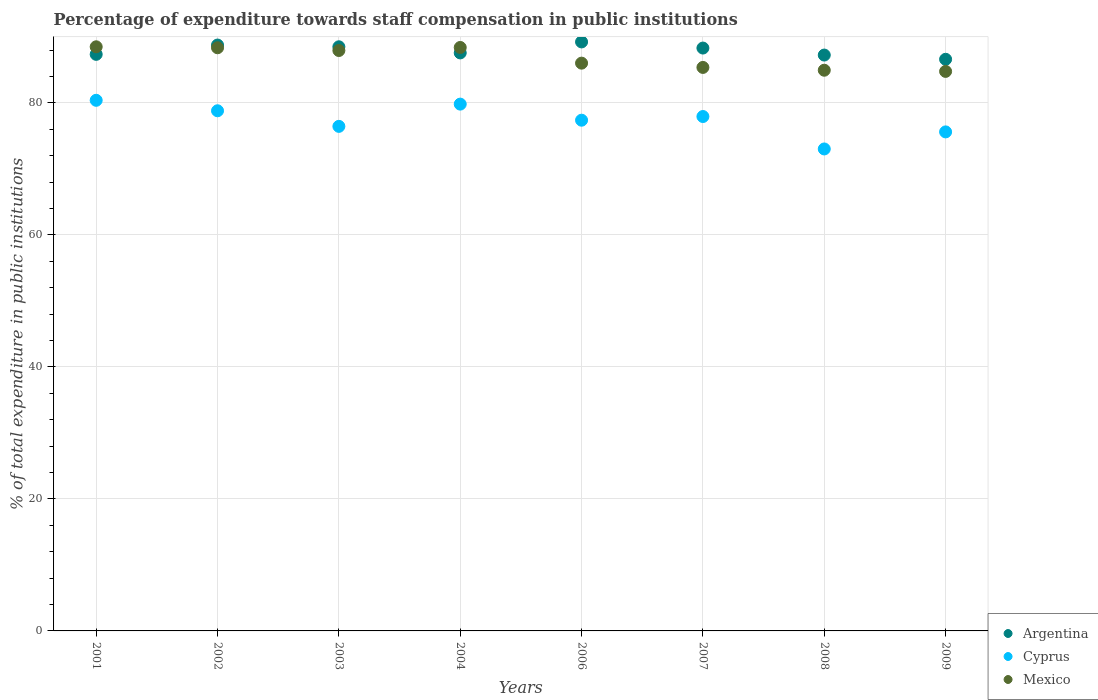Is the number of dotlines equal to the number of legend labels?
Make the answer very short. Yes. What is the percentage of expenditure towards staff compensation in Mexico in 2004?
Provide a short and direct response. 88.4. Across all years, what is the maximum percentage of expenditure towards staff compensation in Mexico?
Your response must be concise. 88.5. Across all years, what is the minimum percentage of expenditure towards staff compensation in Mexico?
Provide a short and direct response. 84.78. In which year was the percentage of expenditure towards staff compensation in Cyprus maximum?
Ensure brevity in your answer.  2001. In which year was the percentage of expenditure towards staff compensation in Argentina minimum?
Give a very brief answer. 2009. What is the total percentage of expenditure towards staff compensation in Mexico in the graph?
Your answer should be compact. 694.34. What is the difference between the percentage of expenditure towards staff compensation in Mexico in 2001 and that in 2009?
Provide a short and direct response. 3.73. What is the difference between the percentage of expenditure towards staff compensation in Mexico in 2002 and the percentage of expenditure towards staff compensation in Cyprus in 2009?
Offer a terse response. 12.75. What is the average percentage of expenditure towards staff compensation in Argentina per year?
Provide a succinct answer. 87.95. In the year 2007, what is the difference between the percentage of expenditure towards staff compensation in Cyprus and percentage of expenditure towards staff compensation in Mexico?
Ensure brevity in your answer.  -7.44. What is the ratio of the percentage of expenditure towards staff compensation in Mexico in 2008 to that in 2009?
Your answer should be very brief. 1. What is the difference between the highest and the second highest percentage of expenditure towards staff compensation in Mexico?
Provide a short and direct response. 0.1. What is the difference between the highest and the lowest percentage of expenditure towards staff compensation in Argentina?
Offer a terse response. 2.63. Is the sum of the percentage of expenditure towards staff compensation in Mexico in 2001 and 2006 greater than the maximum percentage of expenditure towards staff compensation in Cyprus across all years?
Provide a succinct answer. Yes. Does the graph contain grids?
Give a very brief answer. Yes. Where does the legend appear in the graph?
Give a very brief answer. Bottom right. What is the title of the graph?
Make the answer very short. Percentage of expenditure towards staff compensation in public institutions. Does "Upper middle income" appear as one of the legend labels in the graph?
Make the answer very short. No. What is the label or title of the Y-axis?
Offer a terse response. % of total expenditure in public institutions. What is the % of total expenditure in public institutions in Argentina in 2001?
Offer a terse response. 87.36. What is the % of total expenditure in public institutions in Cyprus in 2001?
Keep it short and to the point. 80.4. What is the % of total expenditure in public institutions of Mexico in 2001?
Your answer should be very brief. 88.5. What is the % of total expenditure in public institutions of Argentina in 2002?
Your answer should be very brief. 88.77. What is the % of total expenditure in public institutions in Cyprus in 2002?
Keep it short and to the point. 78.81. What is the % of total expenditure in public institutions in Mexico in 2002?
Make the answer very short. 88.36. What is the % of total expenditure in public institutions of Argentina in 2003?
Keep it short and to the point. 88.51. What is the % of total expenditure in public institutions of Cyprus in 2003?
Offer a terse response. 76.45. What is the % of total expenditure in public institutions of Mexico in 2003?
Make the answer very short. 87.94. What is the % of total expenditure in public institutions of Argentina in 2004?
Make the answer very short. 87.58. What is the % of total expenditure in public institutions of Cyprus in 2004?
Offer a very short reply. 79.82. What is the % of total expenditure in public institutions in Mexico in 2004?
Your response must be concise. 88.4. What is the % of total expenditure in public institutions in Argentina in 2006?
Offer a terse response. 89.24. What is the % of total expenditure in public institutions of Cyprus in 2006?
Give a very brief answer. 77.38. What is the % of total expenditure in public institutions of Mexico in 2006?
Provide a short and direct response. 86.03. What is the % of total expenditure in public institutions in Argentina in 2007?
Provide a short and direct response. 88.31. What is the % of total expenditure in public institutions of Cyprus in 2007?
Provide a short and direct response. 77.94. What is the % of total expenditure in public institutions in Mexico in 2007?
Offer a very short reply. 85.38. What is the % of total expenditure in public institutions in Argentina in 2008?
Make the answer very short. 87.25. What is the % of total expenditure in public institutions of Cyprus in 2008?
Your response must be concise. 73.03. What is the % of total expenditure in public institutions in Mexico in 2008?
Offer a terse response. 84.95. What is the % of total expenditure in public institutions of Argentina in 2009?
Offer a very short reply. 86.61. What is the % of total expenditure in public institutions in Cyprus in 2009?
Ensure brevity in your answer.  75.61. What is the % of total expenditure in public institutions of Mexico in 2009?
Your answer should be very brief. 84.78. Across all years, what is the maximum % of total expenditure in public institutions in Argentina?
Give a very brief answer. 89.24. Across all years, what is the maximum % of total expenditure in public institutions of Cyprus?
Offer a very short reply. 80.4. Across all years, what is the maximum % of total expenditure in public institutions in Mexico?
Your answer should be compact. 88.5. Across all years, what is the minimum % of total expenditure in public institutions of Argentina?
Offer a very short reply. 86.61. Across all years, what is the minimum % of total expenditure in public institutions in Cyprus?
Provide a short and direct response. 73.03. Across all years, what is the minimum % of total expenditure in public institutions of Mexico?
Give a very brief answer. 84.78. What is the total % of total expenditure in public institutions in Argentina in the graph?
Ensure brevity in your answer.  703.63. What is the total % of total expenditure in public institutions in Cyprus in the graph?
Provide a short and direct response. 619.43. What is the total % of total expenditure in public institutions of Mexico in the graph?
Make the answer very short. 694.34. What is the difference between the % of total expenditure in public institutions of Argentina in 2001 and that in 2002?
Ensure brevity in your answer.  -1.41. What is the difference between the % of total expenditure in public institutions in Cyprus in 2001 and that in 2002?
Provide a short and direct response. 1.59. What is the difference between the % of total expenditure in public institutions of Mexico in 2001 and that in 2002?
Provide a short and direct response. 0.15. What is the difference between the % of total expenditure in public institutions of Argentina in 2001 and that in 2003?
Ensure brevity in your answer.  -1.15. What is the difference between the % of total expenditure in public institutions of Cyprus in 2001 and that in 2003?
Provide a succinct answer. 3.95. What is the difference between the % of total expenditure in public institutions of Mexico in 2001 and that in 2003?
Provide a succinct answer. 0.56. What is the difference between the % of total expenditure in public institutions in Argentina in 2001 and that in 2004?
Offer a very short reply. -0.22. What is the difference between the % of total expenditure in public institutions of Cyprus in 2001 and that in 2004?
Provide a short and direct response. 0.58. What is the difference between the % of total expenditure in public institutions of Mexico in 2001 and that in 2004?
Offer a very short reply. 0.1. What is the difference between the % of total expenditure in public institutions in Argentina in 2001 and that in 2006?
Your response must be concise. -1.88. What is the difference between the % of total expenditure in public institutions in Cyprus in 2001 and that in 2006?
Make the answer very short. 3.01. What is the difference between the % of total expenditure in public institutions of Mexico in 2001 and that in 2006?
Make the answer very short. 2.48. What is the difference between the % of total expenditure in public institutions of Argentina in 2001 and that in 2007?
Make the answer very short. -0.95. What is the difference between the % of total expenditure in public institutions of Cyprus in 2001 and that in 2007?
Make the answer very short. 2.46. What is the difference between the % of total expenditure in public institutions of Mexico in 2001 and that in 2007?
Your answer should be compact. 3.13. What is the difference between the % of total expenditure in public institutions of Argentina in 2001 and that in 2008?
Ensure brevity in your answer.  0.1. What is the difference between the % of total expenditure in public institutions in Cyprus in 2001 and that in 2008?
Offer a very short reply. 7.37. What is the difference between the % of total expenditure in public institutions of Mexico in 2001 and that in 2008?
Your answer should be very brief. 3.55. What is the difference between the % of total expenditure in public institutions in Argentina in 2001 and that in 2009?
Ensure brevity in your answer.  0.75. What is the difference between the % of total expenditure in public institutions of Cyprus in 2001 and that in 2009?
Keep it short and to the point. 4.79. What is the difference between the % of total expenditure in public institutions in Mexico in 2001 and that in 2009?
Provide a short and direct response. 3.73. What is the difference between the % of total expenditure in public institutions in Argentina in 2002 and that in 2003?
Give a very brief answer. 0.26. What is the difference between the % of total expenditure in public institutions in Cyprus in 2002 and that in 2003?
Your response must be concise. 2.36. What is the difference between the % of total expenditure in public institutions of Mexico in 2002 and that in 2003?
Provide a succinct answer. 0.41. What is the difference between the % of total expenditure in public institutions in Argentina in 2002 and that in 2004?
Make the answer very short. 1.19. What is the difference between the % of total expenditure in public institutions of Cyprus in 2002 and that in 2004?
Your answer should be very brief. -1.01. What is the difference between the % of total expenditure in public institutions of Mexico in 2002 and that in 2004?
Keep it short and to the point. -0.05. What is the difference between the % of total expenditure in public institutions in Argentina in 2002 and that in 2006?
Provide a short and direct response. -0.47. What is the difference between the % of total expenditure in public institutions in Cyprus in 2002 and that in 2006?
Provide a short and direct response. 1.43. What is the difference between the % of total expenditure in public institutions of Mexico in 2002 and that in 2006?
Offer a terse response. 2.33. What is the difference between the % of total expenditure in public institutions in Argentina in 2002 and that in 2007?
Your response must be concise. 0.46. What is the difference between the % of total expenditure in public institutions in Cyprus in 2002 and that in 2007?
Keep it short and to the point. 0.87. What is the difference between the % of total expenditure in public institutions in Mexico in 2002 and that in 2007?
Provide a succinct answer. 2.98. What is the difference between the % of total expenditure in public institutions of Argentina in 2002 and that in 2008?
Ensure brevity in your answer.  1.52. What is the difference between the % of total expenditure in public institutions of Cyprus in 2002 and that in 2008?
Provide a short and direct response. 5.79. What is the difference between the % of total expenditure in public institutions of Mexico in 2002 and that in 2008?
Your answer should be very brief. 3.4. What is the difference between the % of total expenditure in public institutions of Argentina in 2002 and that in 2009?
Keep it short and to the point. 2.16. What is the difference between the % of total expenditure in public institutions in Cyprus in 2002 and that in 2009?
Ensure brevity in your answer.  3.2. What is the difference between the % of total expenditure in public institutions in Mexico in 2002 and that in 2009?
Provide a succinct answer. 3.58. What is the difference between the % of total expenditure in public institutions in Argentina in 2003 and that in 2004?
Offer a terse response. 0.93. What is the difference between the % of total expenditure in public institutions in Cyprus in 2003 and that in 2004?
Provide a short and direct response. -3.37. What is the difference between the % of total expenditure in public institutions of Mexico in 2003 and that in 2004?
Ensure brevity in your answer.  -0.46. What is the difference between the % of total expenditure in public institutions of Argentina in 2003 and that in 2006?
Your response must be concise. -0.74. What is the difference between the % of total expenditure in public institutions of Cyprus in 2003 and that in 2006?
Make the answer very short. -0.93. What is the difference between the % of total expenditure in public institutions in Mexico in 2003 and that in 2006?
Offer a terse response. 1.92. What is the difference between the % of total expenditure in public institutions in Argentina in 2003 and that in 2007?
Your answer should be very brief. 0.19. What is the difference between the % of total expenditure in public institutions of Cyprus in 2003 and that in 2007?
Your answer should be very brief. -1.49. What is the difference between the % of total expenditure in public institutions of Mexico in 2003 and that in 2007?
Ensure brevity in your answer.  2.56. What is the difference between the % of total expenditure in public institutions of Argentina in 2003 and that in 2008?
Ensure brevity in your answer.  1.25. What is the difference between the % of total expenditure in public institutions of Cyprus in 2003 and that in 2008?
Your answer should be compact. 3.42. What is the difference between the % of total expenditure in public institutions of Mexico in 2003 and that in 2008?
Your answer should be very brief. 2.99. What is the difference between the % of total expenditure in public institutions in Argentina in 2003 and that in 2009?
Your answer should be very brief. 1.89. What is the difference between the % of total expenditure in public institutions of Cyprus in 2003 and that in 2009?
Keep it short and to the point. 0.84. What is the difference between the % of total expenditure in public institutions in Mexico in 2003 and that in 2009?
Your answer should be very brief. 3.17. What is the difference between the % of total expenditure in public institutions of Argentina in 2004 and that in 2006?
Keep it short and to the point. -1.66. What is the difference between the % of total expenditure in public institutions in Cyprus in 2004 and that in 2006?
Provide a succinct answer. 2.44. What is the difference between the % of total expenditure in public institutions of Mexico in 2004 and that in 2006?
Provide a succinct answer. 2.38. What is the difference between the % of total expenditure in public institutions in Argentina in 2004 and that in 2007?
Keep it short and to the point. -0.74. What is the difference between the % of total expenditure in public institutions in Cyprus in 2004 and that in 2007?
Offer a very short reply. 1.88. What is the difference between the % of total expenditure in public institutions in Mexico in 2004 and that in 2007?
Your response must be concise. 3.02. What is the difference between the % of total expenditure in public institutions of Argentina in 2004 and that in 2008?
Ensure brevity in your answer.  0.32. What is the difference between the % of total expenditure in public institutions in Cyprus in 2004 and that in 2008?
Offer a very short reply. 6.79. What is the difference between the % of total expenditure in public institutions in Mexico in 2004 and that in 2008?
Give a very brief answer. 3.45. What is the difference between the % of total expenditure in public institutions of Argentina in 2004 and that in 2009?
Offer a very short reply. 0.97. What is the difference between the % of total expenditure in public institutions in Cyprus in 2004 and that in 2009?
Ensure brevity in your answer.  4.21. What is the difference between the % of total expenditure in public institutions in Mexico in 2004 and that in 2009?
Keep it short and to the point. 3.63. What is the difference between the % of total expenditure in public institutions in Argentina in 2006 and that in 2007?
Offer a terse response. 0.93. What is the difference between the % of total expenditure in public institutions of Cyprus in 2006 and that in 2007?
Offer a very short reply. -0.56. What is the difference between the % of total expenditure in public institutions in Mexico in 2006 and that in 2007?
Your answer should be very brief. 0.65. What is the difference between the % of total expenditure in public institutions of Argentina in 2006 and that in 2008?
Offer a terse response. 1.99. What is the difference between the % of total expenditure in public institutions of Cyprus in 2006 and that in 2008?
Your answer should be very brief. 4.36. What is the difference between the % of total expenditure in public institutions of Mexico in 2006 and that in 2008?
Provide a succinct answer. 1.07. What is the difference between the % of total expenditure in public institutions in Argentina in 2006 and that in 2009?
Make the answer very short. 2.63. What is the difference between the % of total expenditure in public institutions in Cyprus in 2006 and that in 2009?
Your response must be concise. 1.77. What is the difference between the % of total expenditure in public institutions in Mexico in 2006 and that in 2009?
Your answer should be very brief. 1.25. What is the difference between the % of total expenditure in public institutions of Argentina in 2007 and that in 2008?
Your answer should be compact. 1.06. What is the difference between the % of total expenditure in public institutions in Cyprus in 2007 and that in 2008?
Ensure brevity in your answer.  4.91. What is the difference between the % of total expenditure in public institutions of Mexico in 2007 and that in 2008?
Ensure brevity in your answer.  0.42. What is the difference between the % of total expenditure in public institutions in Argentina in 2007 and that in 2009?
Make the answer very short. 1.7. What is the difference between the % of total expenditure in public institutions of Cyprus in 2007 and that in 2009?
Offer a terse response. 2.33. What is the difference between the % of total expenditure in public institutions of Mexico in 2007 and that in 2009?
Keep it short and to the point. 0.6. What is the difference between the % of total expenditure in public institutions in Argentina in 2008 and that in 2009?
Keep it short and to the point. 0.64. What is the difference between the % of total expenditure in public institutions of Cyprus in 2008 and that in 2009?
Your response must be concise. -2.58. What is the difference between the % of total expenditure in public institutions of Mexico in 2008 and that in 2009?
Your answer should be compact. 0.18. What is the difference between the % of total expenditure in public institutions in Argentina in 2001 and the % of total expenditure in public institutions in Cyprus in 2002?
Your answer should be compact. 8.55. What is the difference between the % of total expenditure in public institutions of Argentina in 2001 and the % of total expenditure in public institutions of Mexico in 2002?
Give a very brief answer. -1. What is the difference between the % of total expenditure in public institutions of Cyprus in 2001 and the % of total expenditure in public institutions of Mexico in 2002?
Make the answer very short. -7.96. What is the difference between the % of total expenditure in public institutions of Argentina in 2001 and the % of total expenditure in public institutions of Cyprus in 2003?
Offer a terse response. 10.91. What is the difference between the % of total expenditure in public institutions of Argentina in 2001 and the % of total expenditure in public institutions of Mexico in 2003?
Give a very brief answer. -0.58. What is the difference between the % of total expenditure in public institutions in Cyprus in 2001 and the % of total expenditure in public institutions in Mexico in 2003?
Your response must be concise. -7.55. What is the difference between the % of total expenditure in public institutions of Argentina in 2001 and the % of total expenditure in public institutions of Cyprus in 2004?
Offer a terse response. 7.54. What is the difference between the % of total expenditure in public institutions in Argentina in 2001 and the % of total expenditure in public institutions in Mexico in 2004?
Your answer should be compact. -1.04. What is the difference between the % of total expenditure in public institutions in Cyprus in 2001 and the % of total expenditure in public institutions in Mexico in 2004?
Your answer should be very brief. -8.01. What is the difference between the % of total expenditure in public institutions in Argentina in 2001 and the % of total expenditure in public institutions in Cyprus in 2006?
Give a very brief answer. 9.98. What is the difference between the % of total expenditure in public institutions in Argentina in 2001 and the % of total expenditure in public institutions in Mexico in 2006?
Ensure brevity in your answer.  1.33. What is the difference between the % of total expenditure in public institutions in Cyprus in 2001 and the % of total expenditure in public institutions in Mexico in 2006?
Offer a terse response. -5.63. What is the difference between the % of total expenditure in public institutions in Argentina in 2001 and the % of total expenditure in public institutions in Cyprus in 2007?
Your response must be concise. 9.42. What is the difference between the % of total expenditure in public institutions in Argentina in 2001 and the % of total expenditure in public institutions in Mexico in 2007?
Your answer should be compact. 1.98. What is the difference between the % of total expenditure in public institutions in Cyprus in 2001 and the % of total expenditure in public institutions in Mexico in 2007?
Your response must be concise. -4.98. What is the difference between the % of total expenditure in public institutions in Argentina in 2001 and the % of total expenditure in public institutions in Cyprus in 2008?
Make the answer very short. 14.33. What is the difference between the % of total expenditure in public institutions of Argentina in 2001 and the % of total expenditure in public institutions of Mexico in 2008?
Your answer should be compact. 2.4. What is the difference between the % of total expenditure in public institutions of Cyprus in 2001 and the % of total expenditure in public institutions of Mexico in 2008?
Your answer should be compact. -4.56. What is the difference between the % of total expenditure in public institutions in Argentina in 2001 and the % of total expenditure in public institutions in Cyprus in 2009?
Provide a succinct answer. 11.75. What is the difference between the % of total expenditure in public institutions in Argentina in 2001 and the % of total expenditure in public institutions in Mexico in 2009?
Offer a very short reply. 2.58. What is the difference between the % of total expenditure in public institutions of Cyprus in 2001 and the % of total expenditure in public institutions of Mexico in 2009?
Your answer should be very brief. -4.38. What is the difference between the % of total expenditure in public institutions of Argentina in 2002 and the % of total expenditure in public institutions of Cyprus in 2003?
Keep it short and to the point. 12.32. What is the difference between the % of total expenditure in public institutions of Argentina in 2002 and the % of total expenditure in public institutions of Mexico in 2003?
Offer a terse response. 0.83. What is the difference between the % of total expenditure in public institutions in Cyprus in 2002 and the % of total expenditure in public institutions in Mexico in 2003?
Ensure brevity in your answer.  -9.13. What is the difference between the % of total expenditure in public institutions in Argentina in 2002 and the % of total expenditure in public institutions in Cyprus in 2004?
Make the answer very short. 8.95. What is the difference between the % of total expenditure in public institutions in Argentina in 2002 and the % of total expenditure in public institutions in Mexico in 2004?
Give a very brief answer. 0.37. What is the difference between the % of total expenditure in public institutions in Cyprus in 2002 and the % of total expenditure in public institutions in Mexico in 2004?
Offer a very short reply. -9.59. What is the difference between the % of total expenditure in public institutions in Argentina in 2002 and the % of total expenditure in public institutions in Cyprus in 2006?
Keep it short and to the point. 11.39. What is the difference between the % of total expenditure in public institutions in Argentina in 2002 and the % of total expenditure in public institutions in Mexico in 2006?
Provide a short and direct response. 2.74. What is the difference between the % of total expenditure in public institutions of Cyprus in 2002 and the % of total expenditure in public institutions of Mexico in 2006?
Provide a succinct answer. -7.21. What is the difference between the % of total expenditure in public institutions of Argentina in 2002 and the % of total expenditure in public institutions of Cyprus in 2007?
Your answer should be compact. 10.83. What is the difference between the % of total expenditure in public institutions of Argentina in 2002 and the % of total expenditure in public institutions of Mexico in 2007?
Offer a terse response. 3.39. What is the difference between the % of total expenditure in public institutions in Cyprus in 2002 and the % of total expenditure in public institutions in Mexico in 2007?
Provide a succinct answer. -6.57. What is the difference between the % of total expenditure in public institutions of Argentina in 2002 and the % of total expenditure in public institutions of Cyprus in 2008?
Your answer should be very brief. 15.74. What is the difference between the % of total expenditure in public institutions in Argentina in 2002 and the % of total expenditure in public institutions in Mexico in 2008?
Make the answer very short. 3.81. What is the difference between the % of total expenditure in public institutions in Cyprus in 2002 and the % of total expenditure in public institutions in Mexico in 2008?
Make the answer very short. -6.14. What is the difference between the % of total expenditure in public institutions of Argentina in 2002 and the % of total expenditure in public institutions of Cyprus in 2009?
Provide a short and direct response. 13.16. What is the difference between the % of total expenditure in public institutions in Argentina in 2002 and the % of total expenditure in public institutions in Mexico in 2009?
Keep it short and to the point. 3.99. What is the difference between the % of total expenditure in public institutions in Cyprus in 2002 and the % of total expenditure in public institutions in Mexico in 2009?
Your answer should be compact. -5.97. What is the difference between the % of total expenditure in public institutions in Argentina in 2003 and the % of total expenditure in public institutions in Cyprus in 2004?
Provide a succinct answer. 8.69. What is the difference between the % of total expenditure in public institutions of Argentina in 2003 and the % of total expenditure in public institutions of Mexico in 2004?
Provide a short and direct response. 0.1. What is the difference between the % of total expenditure in public institutions of Cyprus in 2003 and the % of total expenditure in public institutions of Mexico in 2004?
Your answer should be very brief. -11.95. What is the difference between the % of total expenditure in public institutions in Argentina in 2003 and the % of total expenditure in public institutions in Cyprus in 2006?
Ensure brevity in your answer.  11.12. What is the difference between the % of total expenditure in public institutions in Argentina in 2003 and the % of total expenditure in public institutions in Mexico in 2006?
Your answer should be very brief. 2.48. What is the difference between the % of total expenditure in public institutions in Cyprus in 2003 and the % of total expenditure in public institutions in Mexico in 2006?
Your answer should be compact. -9.58. What is the difference between the % of total expenditure in public institutions of Argentina in 2003 and the % of total expenditure in public institutions of Cyprus in 2007?
Your answer should be compact. 10.57. What is the difference between the % of total expenditure in public institutions of Argentina in 2003 and the % of total expenditure in public institutions of Mexico in 2007?
Ensure brevity in your answer.  3.13. What is the difference between the % of total expenditure in public institutions of Cyprus in 2003 and the % of total expenditure in public institutions of Mexico in 2007?
Your answer should be very brief. -8.93. What is the difference between the % of total expenditure in public institutions of Argentina in 2003 and the % of total expenditure in public institutions of Cyprus in 2008?
Provide a short and direct response. 15.48. What is the difference between the % of total expenditure in public institutions in Argentina in 2003 and the % of total expenditure in public institutions in Mexico in 2008?
Your answer should be compact. 3.55. What is the difference between the % of total expenditure in public institutions in Cyprus in 2003 and the % of total expenditure in public institutions in Mexico in 2008?
Offer a terse response. -8.51. What is the difference between the % of total expenditure in public institutions in Argentina in 2003 and the % of total expenditure in public institutions in Cyprus in 2009?
Keep it short and to the point. 12.9. What is the difference between the % of total expenditure in public institutions of Argentina in 2003 and the % of total expenditure in public institutions of Mexico in 2009?
Your answer should be compact. 3.73. What is the difference between the % of total expenditure in public institutions in Cyprus in 2003 and the % of total expenditure in public institutions in Mexico in 2009?
Offer a very short reply. -8.33. What is the difference between the % of total expenditure in public institutions of Argentina in 2004 and the % of total expenditure in public institutions of Cyprus in 2006?
Provide a succinct answer. 10.19. What is the difference between the % of total expenditure in public institutions of Argentina in 2004 and the % of total expenditure in public institutions of Mexico in 2006?
Make the answer very short. 1.55. What is the difference between the % of total expenditure in public institutions of Cyprus in 2004 and the % of total expenditure in public institutions of Mexico in 2006?
Provide a succinct answer. -6.21. What is the difference between the % of total expenditure in public institutions in Argentina in 2004 and the % of total expenditure in public institutions in Cyprus in 2007?
Offer a very short reply. 9.64. What is the difference between the % of total expenditure in public institutions of Argentina in 2004 and the % of total expenditure in public institutions of Mexico in 2007?
Offer a very short reply. 2.2. What is the difference between the % of total expenditure in public institutions in Cyprus in 2004 and the % of total expenditure in public institutions in Mexico in 2007?
Make the answer very short. -5.56. What is the difference between the % of total expenditure in public institutions of Argentina in 2004 and the % of total expenditure in public institutions of Cyprus in 2008?
Offer a very short reply. 14.55. What is the difference between the % of total expenditure in public institutions in Argentina in 2004 and the % of total expenditure in public institutions in Mexico in 2008?
Your answer should be very brief. 2.62. What is the difference between the % of total expenditure in public institutions in Cyprus in 2004 and the % of total expenditure in public institutions in Mexico in 2008?
Provide a short and direct response. -5.14. What is the difference between the % of total expenditure in public institutions of Argentina in 2004 and the % of total expenditure in public institutions of Cyprus in 2009?
Provide a succinct answer. 11.97. What is the difference between the % of total expenditure in public institutions of Argentina in 2004 and the % of total expenditure in public institutions of Mexico in 2009?
Provide a succinct answer. 2.8. What is the difference between the % of total expenditure in public institutions in Cyprus in 2004 and the % of total expenditure in public institutions in Mexico in 2009?
Your response must be concise. -4.96. What is the difference between the % of total expenditure in public institutions of Argentina in 2006 and the % of total expenditure in public institutions of Cyprus in 2007?
Provide a succinct answer. 11.3. What is the difference between the % of total expenditure in public institutions of Argentina in 2006 and the % of total expenditure in public institutions of Mexico in 2007?
Provide a succinct answer. 3.86. What is the difference between the % of total expenditure in public institutions in Cyprus in 2006 and the % of total expenditure in public institutions in Mexico in 2007?
Keep it short and to the point. -8. What is the difference between the % of total expenditure in public institutions in Argentina in 2006 and the % of total expenditure in public institutions in Cyprus in 2008?
Keep it short and to the point. 16.22. What is the difference between the % of total expenditure in public institutions in Argentina in 2006 and the % of total expenditure in public institutions in Mexico in 2008?
Make the answer very short. 4.29. What is the difference between the % of total expenditure in public institutions of Cyprus in 2006 and the % of total expenditure in public institutions of Mexico in 2008?
Ensure brevity in your answer.  -7.57. What is the difference between the % of total expenditure in public institutions in Argentina in 2006 and the % of total expenditure in public institutions in Cyprus in 2009?
Ensure brevity in your answer.  13.63. What is the difference between the % of total expenditure in public institutions of Argentina in 2006 and the % of total expenditure in public institutions of Mexico in 2009?
Keep it short and to the point. 4.47. What is the difference between the % of total expenditure in public institutions in Cyprus in 2006 and the % of total expenditure in public institutions in Mexico in 2009?
Give a very brief answer. -7.39. What is the difference between the % of total expenditure in public institutions in Argentina in 2007 and the % of total expenditure in public institutions in Cyprus in 2008?
Make the answer very short. 15.29. What is the difference between the % of total expenditure in public institutions of Argentina in 2007 and the % of total expenditure in public institutions of Mexico in 2008?
Make the answer very short. 3.36. What is the difference between the % of total expenditure in public institutions in Cyprus in 2007 and the % of total expenditure in public institutions in Mexico in 2008?
Give a very brief answer. -7.01. What is the difference between the % of total expenditure in public institutions in Argentina in 2007 and the % of total expenditure in public institutions in Cyprus in 2009?
Ensure brevity in your answer.  12.7. What is the difference between the % of total expenditure in public institutions of Argentina in 2007 and the % of total expenditure in public institutions of Mexico in 2009?
Make the answer very short. 3.54. What is the difference between the % of total expenditure in public institutions in Cyprus in 2007 and the % of total expenditure in public institutions in Mexico in 2009?
Keep it short and to the point. -6.84. What is the difference between the % of total expenditure in public institutions of Argentina in 2008 and the % of total expenditure in public institutions of Cyprus in 2009?
Ensure brevity in your answer.  11.64. What is the difference between the % of total expenditure in public institutions of Argentina in 2008 and the % of total expenditure in public institutions of Mexico in 2009?
Keep it short and to the point. 2.48. What is the difference between the % of total expenditure in public institutions of Cyprus in 2008 and the % of total expenditure in public institutions of Mexico in 2009?
Provide a short and direct response. -11.75. What is the average % of total expenditure in public institutions in Argentina per year?
Make the answer very short. 87.95. What is the average % of total expenditure in public institutions of Cyprus per year?
Offer a terse response. 77.43. What is the average % of total expenditure in public institutions in Mexico per year?
Your response must be concise. 86.79. In the year 2001, what is the difference between the % of total expenditure in public institutions in Argentina and % of total expenditure in public institutions in Cyprus?
Your response must be concise. 6.96. In the year 2001, what is the difference between the % of total expenditure in public institutions in Argentina and % of total expenditure in public institutions in Mexico?
Your response must be concise. -1.15. In the year 2001, what is the difference between the % of total expenditure in public institutions in Cyprus and % of total expenditure in public institutions in Mexico?
Your answer should be compact. -8.11. In the year 2002, what is the difference between the % of total expenditure in public institutions in Argentina and % of total expenditure in public institutions in Cyprus?
Keep it short and to the point. 9.96. In the year 2002, what is the difference between the % of total expenditure in public institutions of Argentina and % of total expenditure in public institutions of Mexico?
Give a very brief answer. 0.41. In the year 2002, what is the difference between the % of total expenditure in public institutions in Cyprus and % of total expenditure in public institutions in Mexico?
Provide a short and direct response. -9.55. In the year 2003, what is the difference between the % of total expenditure in public institutions in Argentina and % of total expenditure in public institutions in Cyprus?
Provide a succinct answer. 12.06. In the year 2003, what is the difference between the % of total expenditure in public institutions in Argentina and % of total expenditure in public institutions in Mexico?
Keep it short and to the point. 0.56. In the year 2003, what is the difference between the % of total expenditure in public institutions of Cyprus and % of total expenditure in public institutions of Mexico?
Make the answer very short. -11.49. In the year 2004, what is the difference between the % of total expenditure in public institutions of Argentina and % of total expenditure in public institutions of Cyprus?
Keep it short and to the point. 7.76. In the year 2004, what is the difference between the % of total expenditure in public institutions of Argentina and % of total expenditure in public institutions of Mexico?
Your response must be concise. -0.83. In the year 2004, what is the difference between the % of total expenditure in public institutions of Cyprus and % of total expenditure in public institutions of Mexico?
Offer a terse response. -8.58. In the year 2006, what is the difference between the % of total expenditure in public institutions in Argentina and % of total expenditure in public institutions in Cyprus?
Your answer should be compact. 11.86. In the year 2006, what is the difference between the % of total expenditure in public institutions of Argentina and % of total expenditure in public institutions of Mexico?
Your response must be concise. 3.22. In the year 2006, what is the difference between the % of total expenditure in public institutions of Cyprus and % of total expenditure in public institutions of Mexico?
Offer a very short reply. -8.64. In the year 2007, what is the difference between the % of total expenditure in public institutions of Argentina and % of total expenditure in public institutions of Cyprus?
Offer a very short reply. 10.37. In the year 2007, what is the difference between the % of total expenditure in public institutions of Argentina and % of total expenditure in public institutions of Mexico?
Offer a terse response. 2.93. In the year 2007, what is the difference between the % of total expenditure in public institutions of Cyprus and % of total expenditure in public institutions of Mexico?
Offer a very short reply. -7.44. In the year 2008, what is the difference between the % of total expenditure in public institutions in Argentina and % of total expenditure in public institutions in Cyprus?
Your answer should be very brief. 14.23. In the year 2008, what is the difference between the % of total expenditure in public institutions of Argentina and % of total expenditure in public institutions of Mexico?
Your answer should be compact. 2.3. In the year 2008, what is the difference between the % of total expenditure in public institutions in Cyprus and % of total expenditure in public institutions in Mexico?
Keep it short and to the point. -11.93. In the year 2009, what is the difference between the % of total expenditure in public institutions in Argentina and % of total expenditure in public institutions in Cyprus?
Make the answer very short. 11. In the year 2009, what is the difference between the % of total expenditure in public institutions of Argentina and % of total expenditure in public institutions of Mexico?
Make the answer very short. 1.84. In the year 2009, what is the difference between the % of total expenditure in public institutions in Cyprus and % of total expenditure in public institutions in Mexico?
Offer a very short reply. -9.17. What is the ratio of the % of total expenditure in public institutions in Argentina in 2001 to that in 2002?
Your answer should be very brief. 0.98. What is the ratio of the % of total expenditure in public institutions of Cyprus in 2001 to that in 2002?
Provide a succinct answer. 1.02. What is the ratio of the % of total expenditure in public institutions of Cyprus in 2001 to that in 2003?
Your response must be concise. 1.05. What is the ratio of the % of total expenditure in public institutions in Mexico in 2001 to that in 2003?
Offer a very short reply. 1.01. What is the ratio of the % of total expenditure in public institutions in Cyprus in 2001 to that in 2004?
Offer a terse response. 1.01. What is the ratio of the % of total expenditure in public institutions in Mexico in 2001 to that in 2004?
Provide a short and direct response. 1. What is the ratio of the % of total expenditure in public institutions of Argentina in 2001 to that in 2006?
Give a very brief answer. 0.98. What is the ratio of the % of total expenditure in public institutions of Cyprus in 2001 to that in 2006?
Make the answer very short. 1.04. What is the ratio of the % of total expenditure in public institutions of Mexico in 2001 to that in 2006?
Offer a terse response. 1.03. What is the ratio of the % of total expenditure in public institutions of Argentina in 2001 to that in 2007?
Offer a very short reply. 0.99. What is the ratio of the % of total expenditure in public institutions in Cyprus in 2001 to that in 2007?
Offer a very short reply. 1.03. What is the ratio of the % of total expenditure in public institutions of Mexico in 2001 to that in 2007?
Keep it short and to the point. 1.04. What is the ratio of the % of total expenditure in public institutions of Cyprus in 2001 to that in 2008?
Provide a succinct answer. 1.1. What is the ratio of the % of total expenditure in public institutions of Mexico in 2001 to that in 2008?
Ensure brevity in your answer.  1.04. What is the ratio of the % of total expenditure in public institutions of Argentina in 2001 to that in 2009?
Make the answer very short. 1.01. What is the ratio of the % of total expenditure in public institutions of Cyprus in 2001 to that in 2009?
Ensure brevity in your answer.  1.06. What is the ratio of the % of total expenditure in public institutions in Mexico in 2001 to that in 2009?
Offer a terse response. 1.04. What is the ratio of the % of total expenditure in public institutions of Argentina in 2002 to that in 2003?
Give a very brief answer. 1. What is the ratio of the % of total expenditure in public institutions of Cyprus in 2002 to that in 2003?
Give a very brief answer. 1.03. What is the ratio of the % of total expenditure in public institutions of Mexico in 2002 to that in 2003?
Your response must be concise. 1. What is the ratio of the % of total expenditure in public institutions in Argentina in 2002 to that in 2004?
Your response must be concise. 1.01. What is the ratio of the % of total expenditure in public institutions of Cyprus in 2002 to that in 2004?
Your answer should be compact. 0.99. What is the ratio of the % of total expenditure in public institutions of Cyprus in 2002 to that in 2006?
Offer a very short reply. 1.02. What is the ratio of the % of total expenditure in public institutions of Mexico in 2002 to that in 2006?
Provide a succinct answer. 1.03. What is the ratio of the % of total expenditure in public institutions in Argentina in 2002 to that in 2007?
Provide a short and direct response. 1.01. What is the ratio of the % of total expenditure in public institutions in Cyprus in 2002 to that in 2007?
Provide a succinct answer. 1.01. What is the ratio of the % of total expenditure in public institutions of Mexico in 2002 to that in 2007?
Offer a very short reply. 1.03. What is the ratio of the % of total expenditure in public institutions of Argentina in 2002 to that in 2008?
Your answer should be compact. 1.02. What is the ratio of the % of total expenditure in public institutions in Cyprus in 2002 to that in 2008?
Give a very brief answer. 1.08. What is the ratio of the % of total expenditure in public institutions of Mexico in 2002 to that in 2008?
Offer a terse response. 1.04. What is the ratio of the % of total expenditure in public institutions in Argentina in 2002 to that in 2009?
Offer a very short reply. 1.02. What is the ratio of the % of total expenditure in public institutions in Cyprus in 2002 to that in 2009?
Your response must be concise. 1.04. What is the ratio of the % of total expenditure in public institutions of Mexico in 2002 to that in 2009?
Offer a very short reply. 1.04. What is the ratio of the % of total expenditure in public institutions of Argentina in 2003 to that in 2004?
Your response must be concise. 1.01. What is the ratio of the % of total expenditure in public institutions in Cyprus in 2003 to that in 2004?
Make the answer very short. 0.96. What is the ratio of the % of total expenditure in public institutions in Mexico in 2003 to that in 2004?
Ensure brevity in your answer.  0.99. What is the ratio of the % of total expenditure in public institutions of Argentina in 2003 to that in 2006?
Your response must be concise. 0.99. What is the ratio of the % of total expenditure in public institutions of Cyprus in 2003 to that in 2006?
Provide a succinct answer. 0.99. What is the ratio of the % of total expenditure in public institutions in Mexico in 2003 to that in 2006?
Provide a short and direct response. 1.02. What is the ratio of the % of total expenditure in public institutions in Argentina in 2003 to that in 2007?
Your answer should be compact. 1. What is the ratio of the % of total expenditure in public institutions in Cyprus in 2003 to that in 2007?
Make the answer very short. 0.98. What is the ratio of the % of total expenditure in public institutions in Argentina in 2003 to that in 2008?
Make the answer very short. 1.01. What is the ratio of the % of total expenditure in public institutions in Cyprus in 2003 to that in 2008?
Your answer should be compact. 1.05. What is the ratio of the % of total expenditure in public institutions in Mexico in 2003 to that in 2008?
Your answer should be very brief. 1.04. What is the ratio of the % of total expenditure in public institutions in Argentina in 2003 to that in 2009?
Keep it short and to the point. 1.02. What is the ratio of the % of total expenditure in public institutions of Cyprus in 2003 to that in 2009?
Give a very brief answer. 1.01. What is the ratio of the % of total expenditure in public institutions in Mexico in 2003 to that in 2009?
Your answer should be compact. 1.04. What is the ratio of the % of total expenditure in public institutions of Argentina in 2004 to that in 2006?
Provide a succinct answer. 0.98. What is the ratio of the % of total expenditure in public institutions in Cyprus in 2004 to that in 2006?
Offer a terse response. 1.03. What is the ratio of the % of total expenditure in public institutions in Mexico in 2004 to that in 2006?
Offer a very short reply. 1.03. What is the ratio of the % of total expenditure in public institutions in Argentina in 2004 to that in 2007?
Offer a very short reply. 0.99. What is the ratio of the % of total expenditure in public institutions in Cyprus in 2004 to that in 2007?
Ensure brevity in your answer.  1.02. What is the ratio of the % of total expenditure in public institutions of Mexico in 2004 to that in 2007?
Provide a succinct answer. 1.04. What is the ratio of the % of total expenditure in public institutions in Cyprus in 2004 to that in 2008?
Offer a very short reply. 1.09. What is the ratio of the % of total expenditure in public institutions of Mexico in 2004 to that in 2008?
Provide a succinct answer. 1.04. What is the ratio of the % of total expenditure in public institutions in Argentina in 2004 to that in 2009?
Your answer should be compact. 1.01. What is the ratio of the % of total expenditure in public institutions of Cyprus in 2004 to that in 2009?
Offer a terse response. 1.06. What is the ratio of the % of total expenditure in public institutions of Mexico in 2004 to that in 2009?
Your response must be concise. 1.04. What is the ratio of the % of total expenditure in public institutions of Argentina in 2006 to that in 2007?
Offer a terse response. 1.01. What is the ratio of the % of total expenditure in public institutions of Mexico in 2006 to that in 2007?
Provide a short and direct response. 1.01. What is the ratio of the % of total expenditure in public institutions in Argentina in 2006 to that in 2008?
Your answer should be very brief. 1.02. What is the ratio of the % of total expenditure in public institutions of Cyprus in 2006 to that in 2008?
Provide a succinct answer. 1.06. What is the ratio of the % of total expenditure in public institutions in Mexico in 2006 to that in 2008?
Your response must be concise. 1.01. What is the ratio of the % of total expenditure in public institutions of Argentina in 2006 to that in 2009?
Give a very brief answer. 1.03. What is the ratio of the % of total expenditure in public institutions of Cyprus in 2006 to that in 2009?
Give a very brief answer. 1.02. What is the ratio of the % of total expenditure in public institutions of Mexico in 2006 to that in 2009?
Give a very brief answer. 1.01. What is the ratio of the % of total expenditure in public institutions of Argentina in 2007 to that in 2008?
Provide a short and direct response. 1.01. What is the ratio of the % of total expenditure in public institutions in Cyprus in 2007 to that in 2008?
Your response must be concise. 1.07. What is the ratio of the % of total expenditure in public institutions of Argentina in 2007 to that in 2009?
Provide a succinct answer. 1.02. What is the ratio of the % of total expenditure in public institutions in Cyprus in 2007 to that in 2009?
Offer a very short reply. 1.03. What is the ratio of the % of total expenditure in public institutions of Mexico in 2007 to that in 2009?
Provide a short and direct response. 1.01. What is the ratio of the % of total expenditure in public institutions in Argentina in 2008 to that in 2009?
Keep it short and to the point. 1.01. What is the ratio of the % of total expenditure in public institutions of Cyprus in 2008 to that in 2009?
Keep it short and to the point. 0.97. What is the ratio of the % of total expenditure in public institutions of Mexico in 2008 to that in 2009?
Your answer should be compact. 1. What is the difference between the highest and the second highest % of total expenditure in public institutions in Argentina?
Offer a very short reply. 0.47. What is the difference between the highest and the second highest % of total expenditure in public institutions of Cyprus?
Ensure brevity in your answer.  0.58. What is the difference between the highest and the second highest % of total expenditure in public institutions of Mexico?
Your answer should be compact. 0.1. What is the difference between the highest and the lowest % of total expenditure in public institutions of Argentina?
Your response must be concise. 2.63. What is the difference between the highest and the lowest % of total expenditure in public institutions of Cyprus?
Offer a terse response. 7.37. What is the difference between the highest and the lowest % of total expenditure in public institutions of Mexico?
Ensure brevity in your answer.  3.73. 